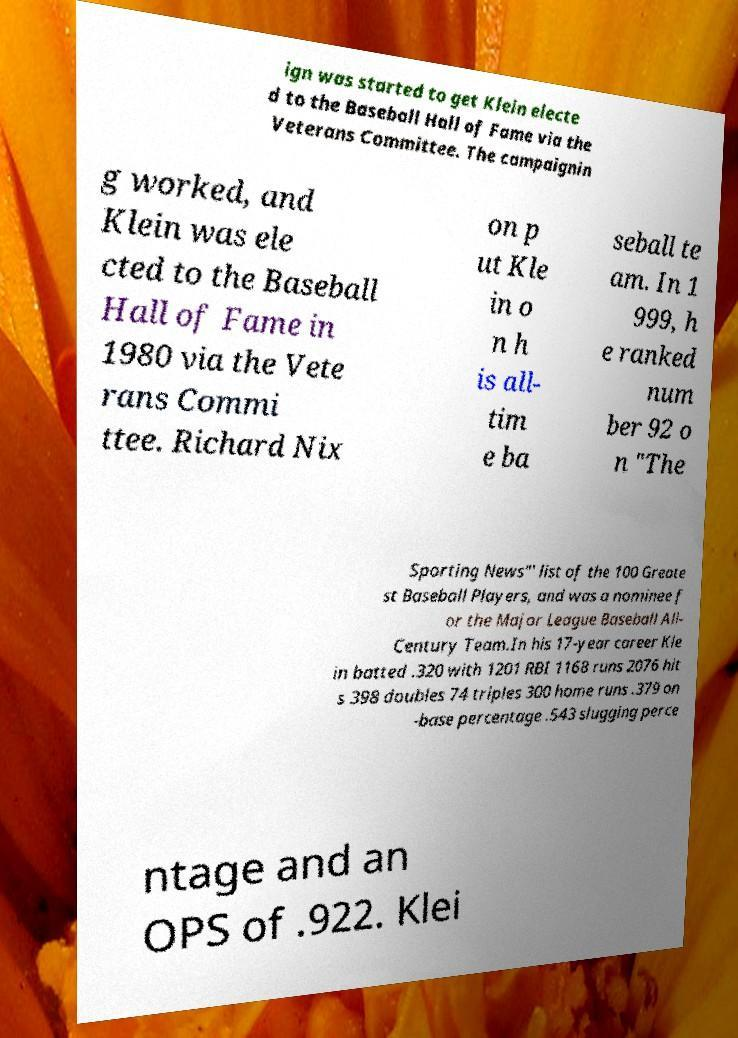Can you read and provide the text displayed in the image?This photo seems to have some interesting text. Can you extract and type it out for me? ign was started to get Klein electe d to the Baseball Hall of Fame via the Veterans Committee. The campaignin g worked, and Klein was ele cted to the Baseball Hall of Fame in 1980 via the Vete rans Commi ttee. Richard Nix on p ut Kle in o n h is all- tim e ba seball te am. In 1 999, h e ranked num ber 92 o n "The Sporting News"' list of the 100 Greate st Baseball Players, and was a nominee f or the Major League Baseball All- Century Team.In his 17-year career Kle in batted .320 with 1201 RBI 1168 runs 2076 hit s 398 doubles 74 triples 300 home runs .379 on -base percentage .543 slugging perce ntage and an OPS of .922. Klei 